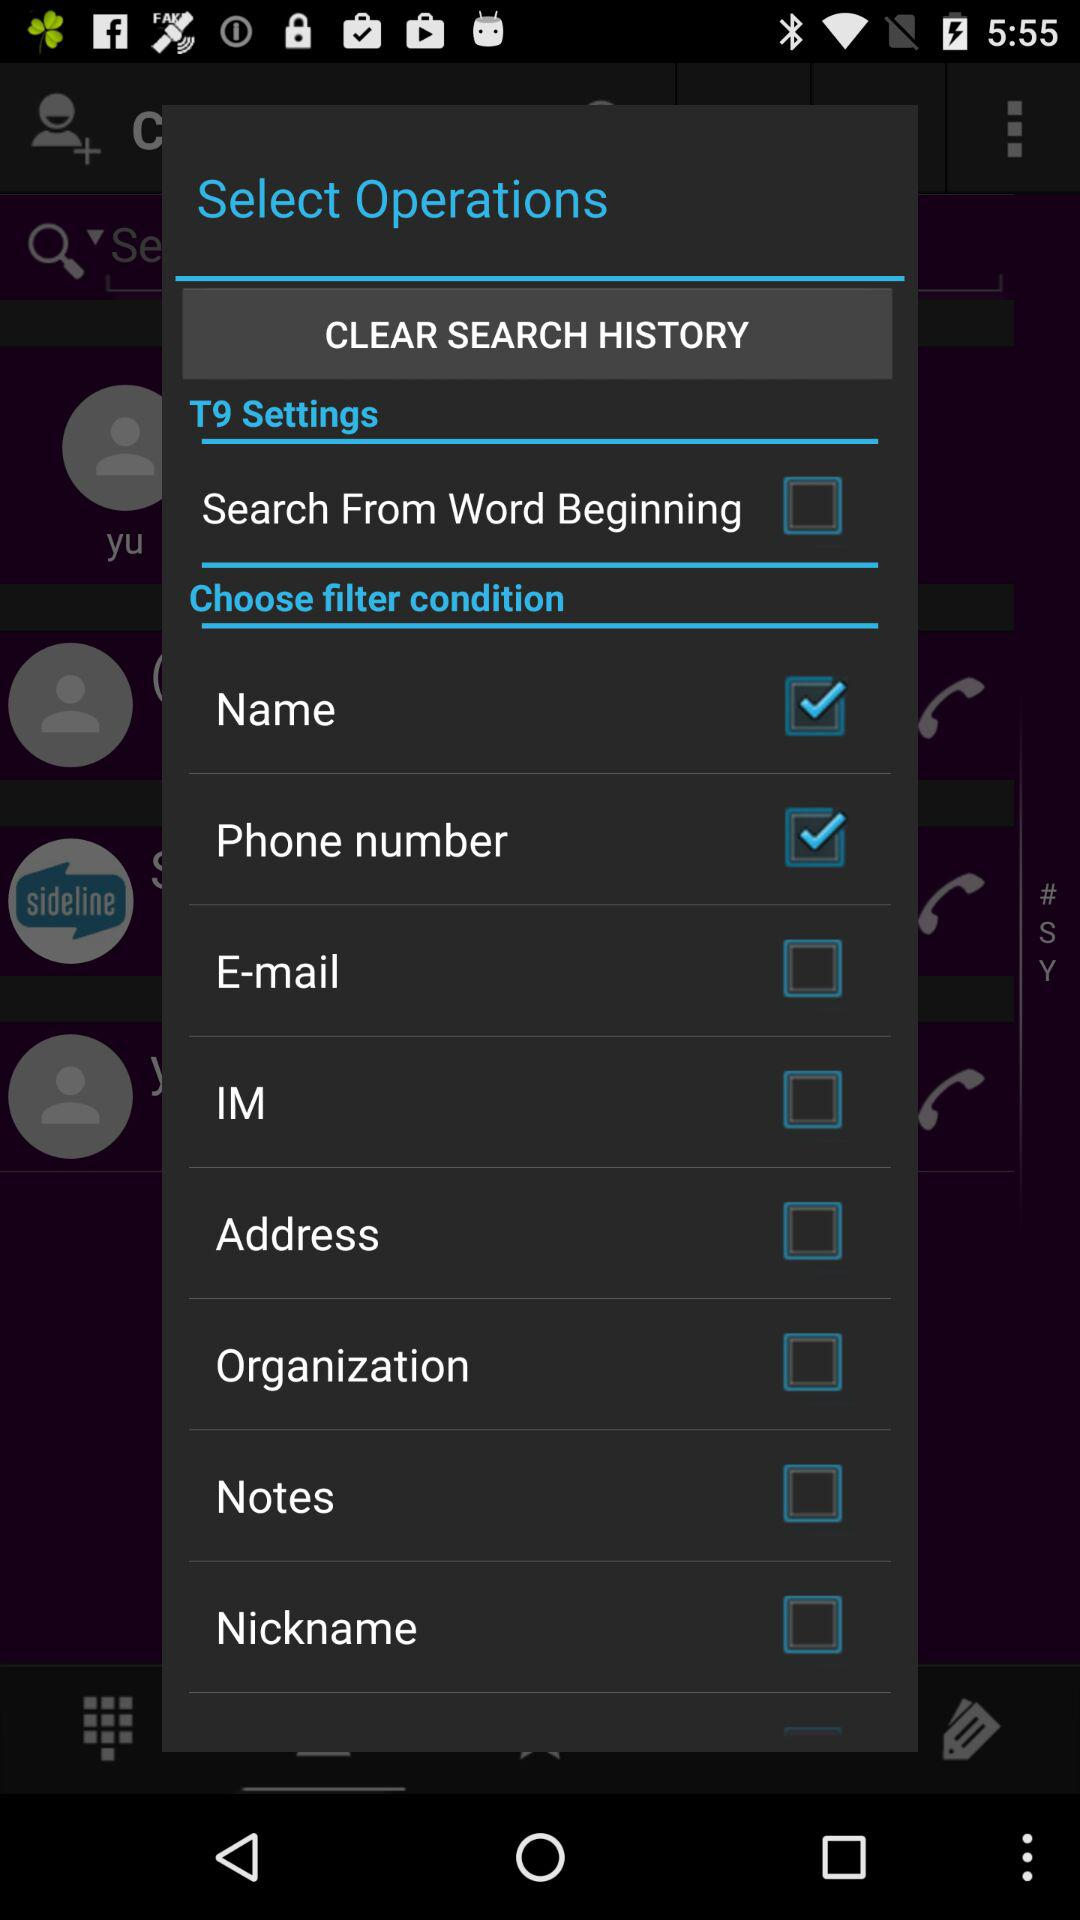What option is in the T9 settings? The option in the T9 settings is "Search From Word Beginning". 